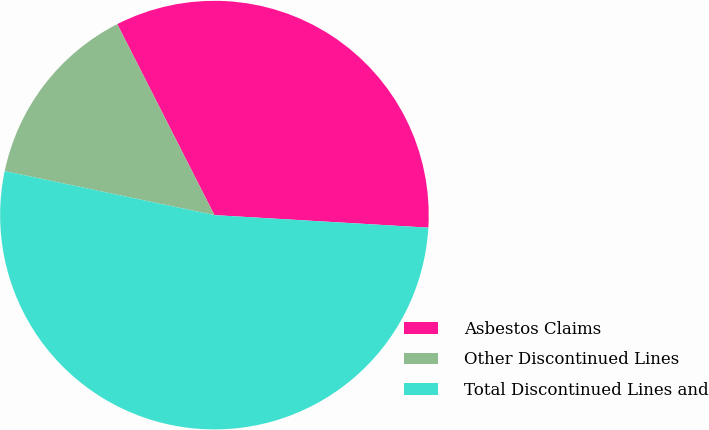<chart> <loc_0><loc_0><loc_500><loc_500><pie_chart><fcel>Asbestos Claims<fcel>Other Discontinued Lines<fcel>Total Discontinued Lines and<nl><fcel>33.42%<fcel>14.22%<fcel>52.36%<nl></chart> 